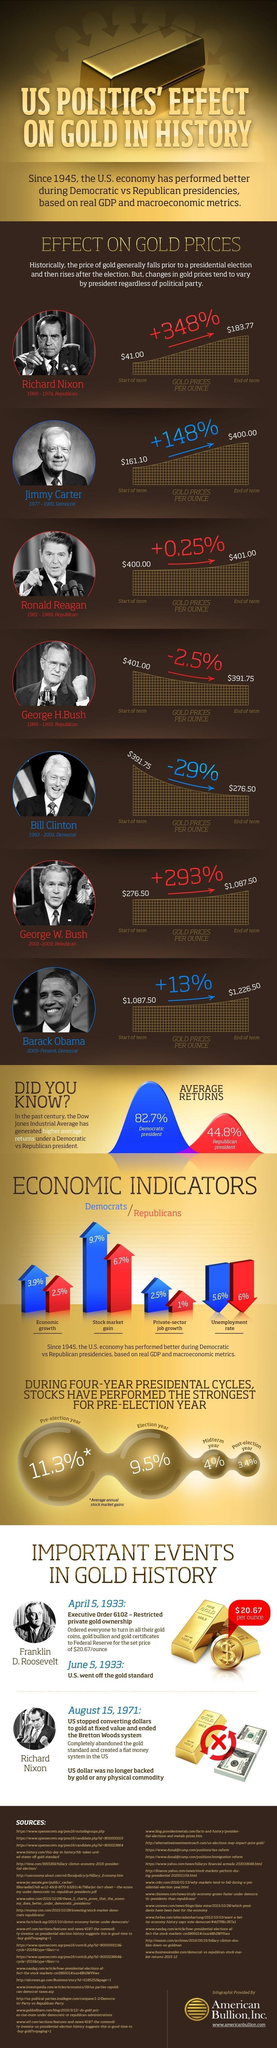In which year, George W. Bush became the president of the U.S.?
Answer the question with a short phrase. 2001 What percentage is the stock market gain during Democratic Presidencies since 1945? 9.7% Who was the U.S. president before George H. Bush? Ronald Reagan What is the average annual stock market gain percentage in the election year? 9.5% What is the percentage increase in the gold prices per ounce during the presidency of Barack Obama? +13% Who was the U.S. president after George W. Bush? Barack Obama What is the decrease in the unemployment rate during Republican Presidencies since 1945? 6% Who was the U.S. president during 1977-1981? Jimmy Carter What is the percentage of economic growth during Democratic Presidencies since 1945? 3.9% Which political party does Bill Clinton belong to? Democrat 